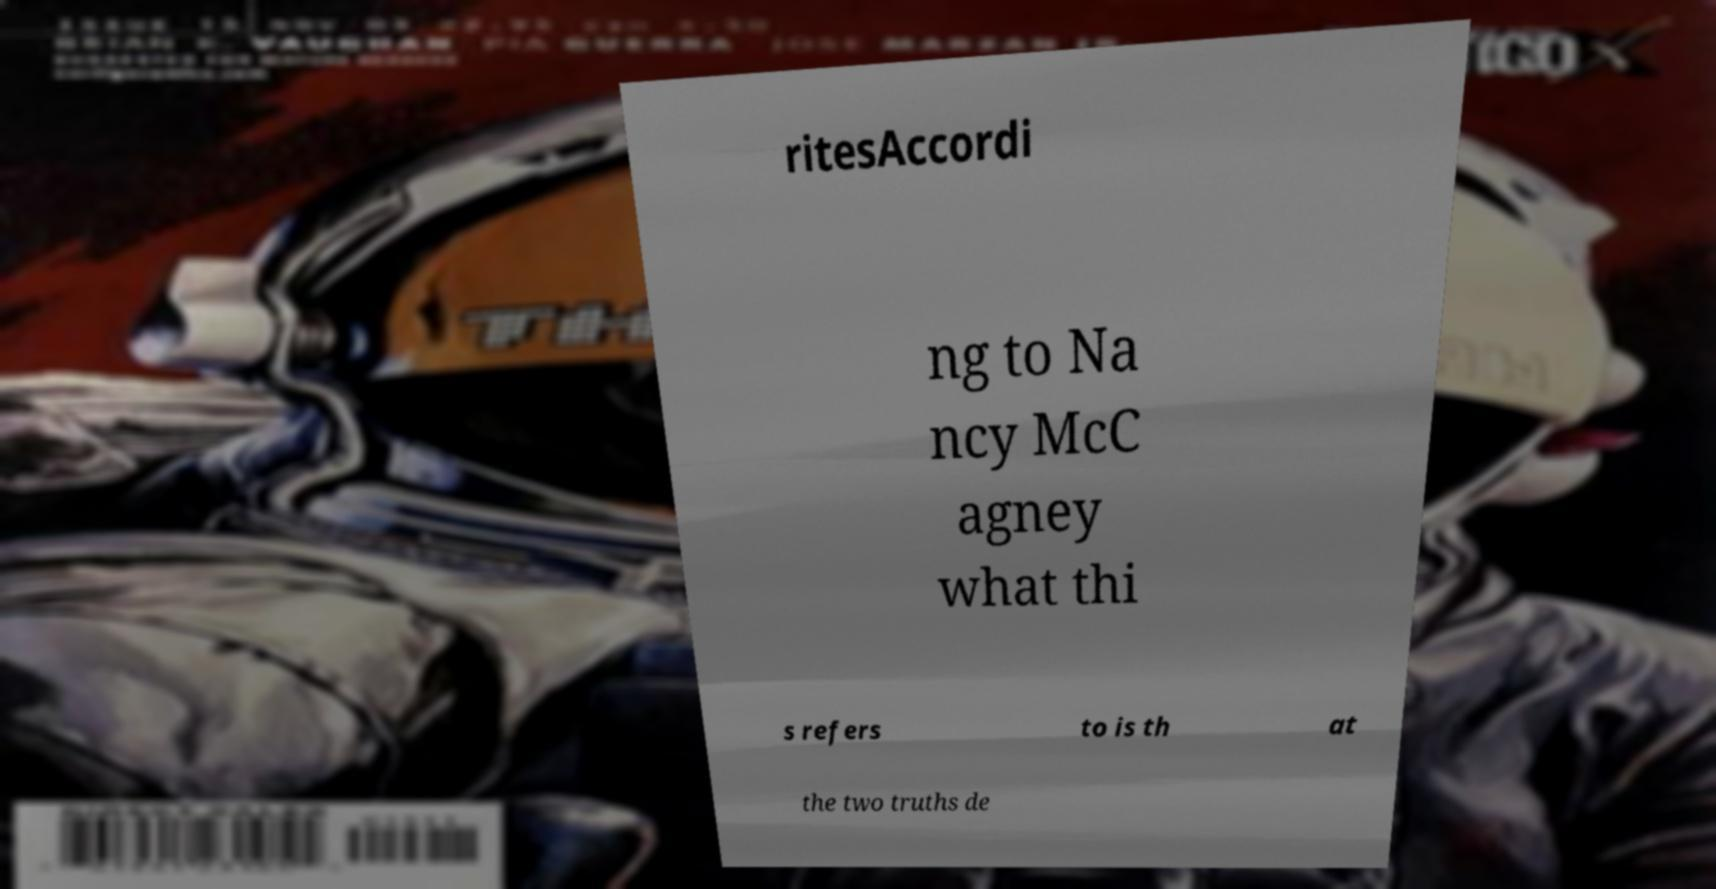For documentation purposes, I need the text within this image transcribed. Could you provide that? ritesAccordi ng to Na ncy McC agney what thi s refers to is th at the two truths de 